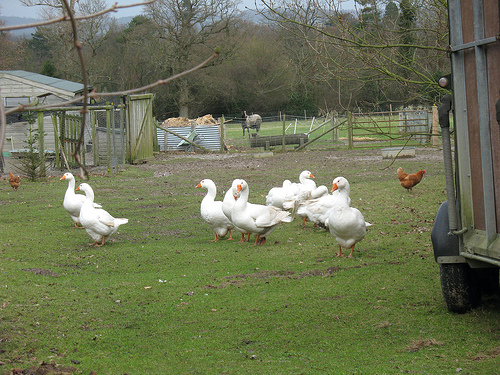<image>
Is the horse behind the fence? Yes. From this viewpoint, the horse is positioned behind the fence, with the fence partially or fully occluding the horse. 